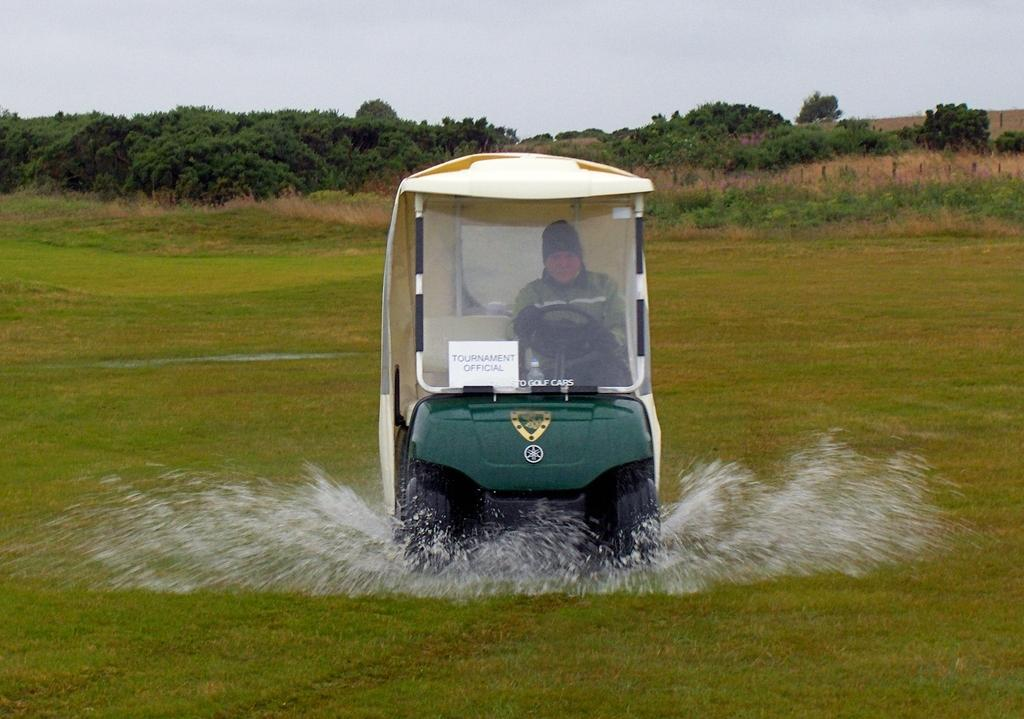What is the person in the image doing? There is a person riding a vehicle in the image. What can be seen in the background of the image? The sky is visible in the background of the image. What type of environment is depicted in the image? There is water, grass, and trees visible in the image, suggesting a natural setting. What else can be seen in the image besides the person and the vehicle? There is a poster in the image. What type of smoke can be seen coming from the vehicle in the image? There is no smoke visible in the image. 